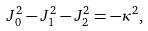Convert formula to latex. <formula><loc_0><loc_0><loc_500><loc_500>J _ { 0 } ^ { 2 } - J _ { 1 } ^ { 2 } - J _ { 2 } ^ { 2 } = - \kappa ^ { 2 } ,</formula> 